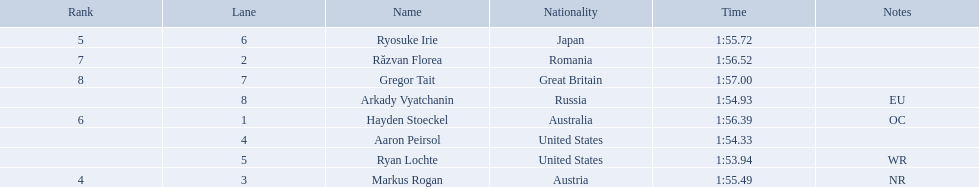What is the name of the contestant in lane 6? Ryosuke Irie. How long did it take that player to complete the race? 1:55.72. 